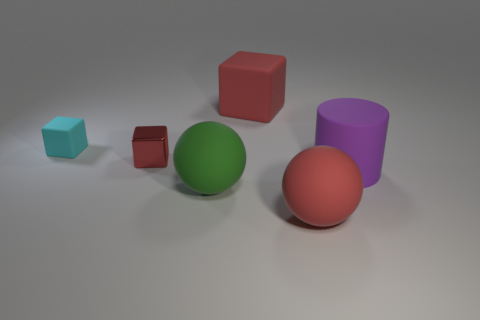What is the shape of the green thing that is the same material as the red sphere?
Offer a terse response. Sphere. Is there any other thing that has the same color as the tiny rubber thing?
Make the answer very short. No. Is the number of small red things that are in front of the big green rubber object greater than the number of tiny red blocks?
Your response must be concise. No. What is the material of the cyan object?
Your answer should be very brief. Rubber. What number of green rubber objects are the same size as the purple rubber cylinder?
Your answer should be very brief. 1. Are there the same number of small rubber things that are in front of the large purple rubber cylinder and big matte cubes right of the large red rubber ball?
Give a very brief answer. Yes. Do the green object and the large purple thing have the same material?
Your answer should be very brief. Yes. Are there any balls that are behind the tiny block that is right of the cyan block?
Your answer should be compact. No. Are there any large purple objects that have the same shape as the small matte thing?
Make the answer very short. No. Do the shiny object and the large cylinder have the same color?
Make the answer very short. No. 